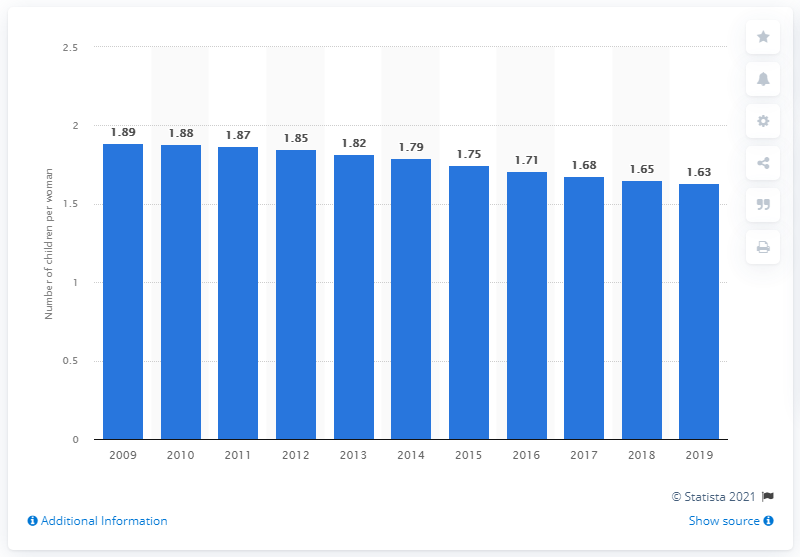Draw attention to some important aspects in this diagram. The fertility rate in Chile in 2019 was 1.63 children per woman. 